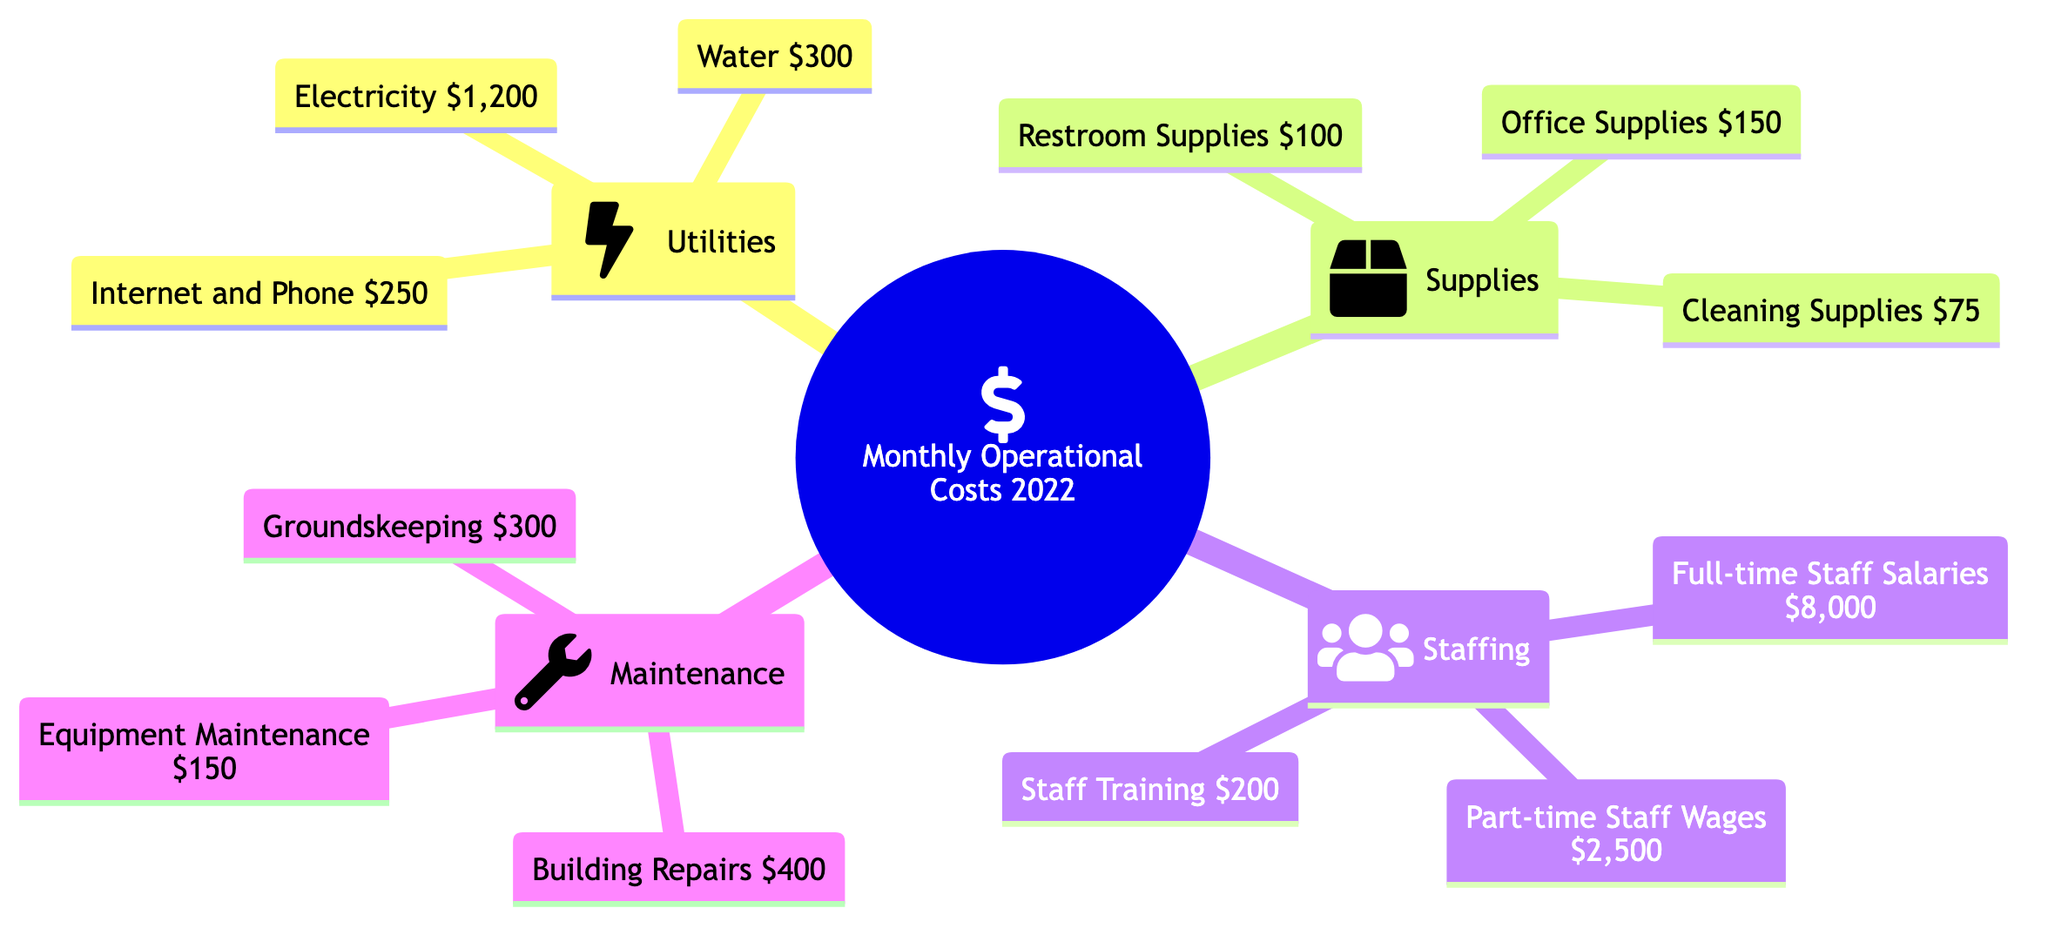What is the total amount spent on Utilities? To find the total amount spent on Utilities, we need to sum the expenses listed under the Utilities category: Electricity ($1,200) + Water ($300) + Internet and Phone ($250). Therefore, the calculation is 1,200 + 300 + 250 = 1,750.
Answer: 1,750 How much is spent on Full-time Staff Salaries? The diagram specifies the amount spent on Full-time Staff Salaries directly under the Staffing category, which is $8,000.
Answer: 8,000 What is the amount allocated for Restroom Supplies? Under the Supplies category, Restroom Supplies is listed as $100. This is a direct lookup from the diagram.
Answer: 100 How many categories of expenses are represented in the diagram? The diagram has four categories of expenses: Utilities, Supplies, Staffing, and Maintenance. This is counted directly from the main nodes in the diagram.
Answer: 4 What is the total cost for Maintenance? To find the total cost for Maintenance, we need to sum the expenses listed under that category: Building Repairs ($400) + Groundskeeping ($300) + Equipment Maintenance ($150). This totals to 400 + 300 + 150 = 850.
Answer: 850 Which category has the highest expense? By comparing the total expenses in each category: Utilities ($1,750), Supplies ($325), Staffing ($10,700), and Maintenance ($850), Staffing has the highest total expense.
Answer: Staffing What is the total monthly operational cost for the Visitor Center? We add all the expenses from each category: Utilities ($1,750) + Supplies ($325) + Staffing ($10,700) + Maintenance ($850). The total calculation results in 1,750 + 325 + 10,700 + 850 = 13,625.
Answer: 13,625 What is the cost of Equipment Maintenance? The diagram shows that Equipment Maintenance costs $150, which we can find directly listed under the Maintenance category.
Answer: 150 How does the cost of Internet and Phone compare to Water? The cost of Internet and Phone is $250, while Water costs $300. Comparing these two, Water ($300) is greater than Internet and Phone ($250).
Answer: Water is greater 